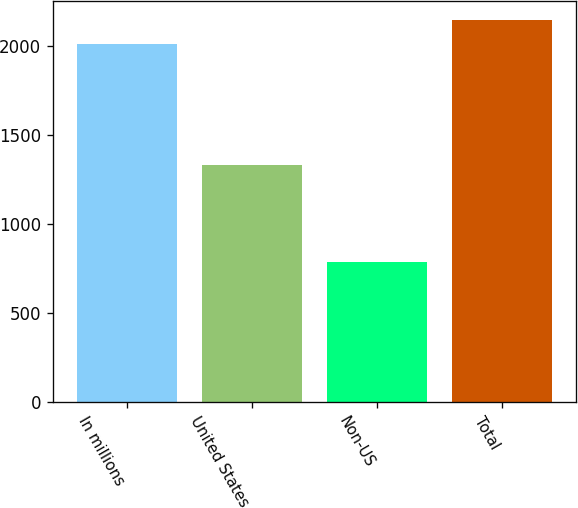Convert chart to OTSL. <chart><loc_0><loc_0><loc_500><loc_500><bar_chart><fcel>In millions<fcel>United States<fcel>Non-US<fcel>Total<nl><fcel>2014<fcel>1332<fcel>786.3<fcel>2147.2<nl></chart> 